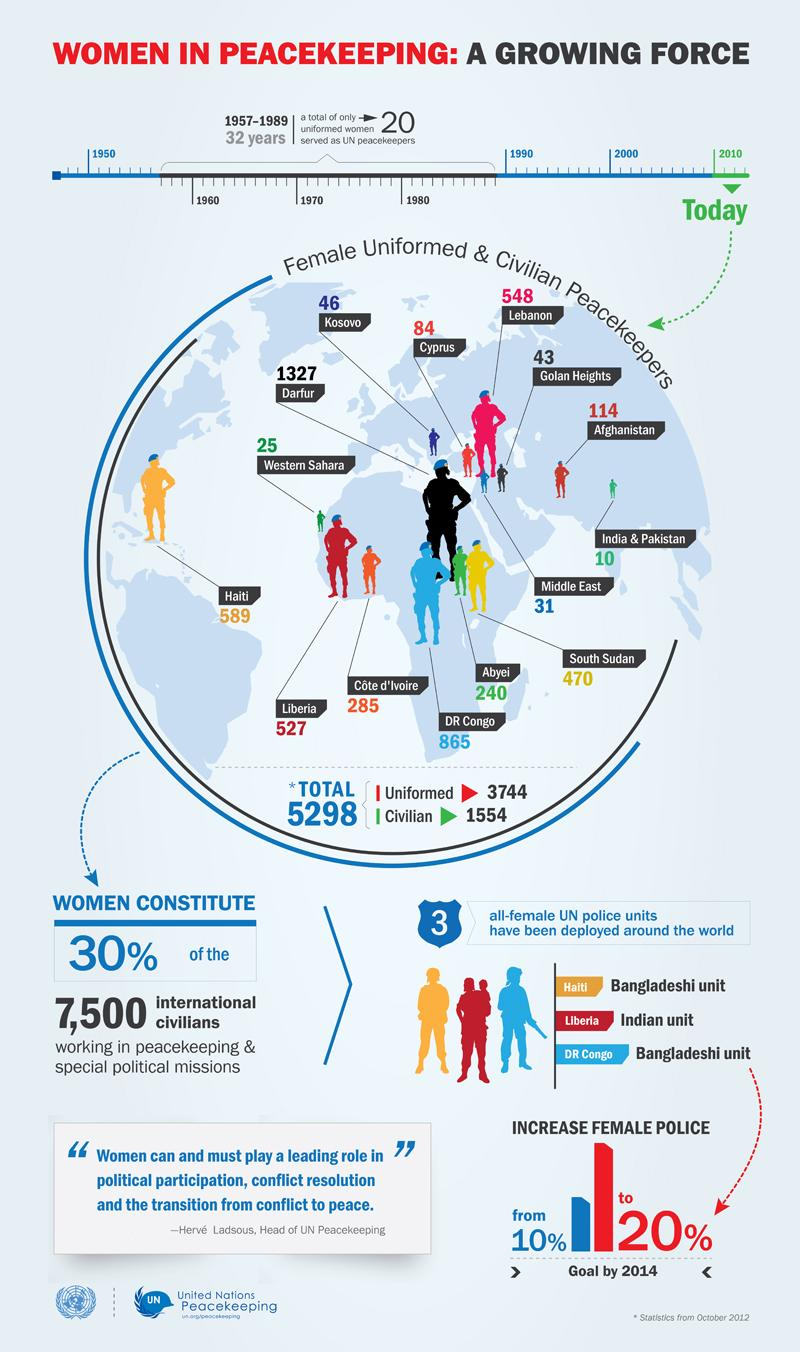Draw attention to some important aspects in this diagram. The difference between the current percentage of female police officers and the planned percentage by 2014 is 10%. The Bangladeshi unit is based in the Democratic Republic of the Congo. As of my knowledge cutoff in 2021, the total count of female peacekeeping force in Kosovo and Cyprus was 130. From 1990 to 2010, there has been a significant increase in the number of female soldiers participating in peacekeeping missions, with a total increase of 1,534. This trend indicates a growing recognition of the important role that women play in maintaining international peace and security, and a commitment to promoting gender equality in the military. The Democratic Republic of the Congo has the second highest number of female peacekeeping forces among all countries. 